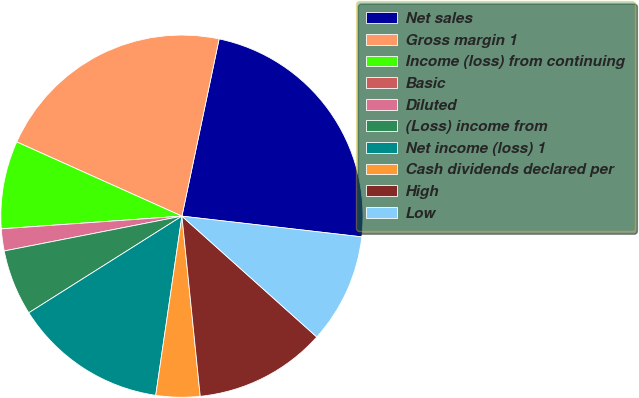<chart> <loc_0><loc_0><loc_500><loc_500><pie_chart><fcel>Net sales<fcel>Gross margin 1<fcel>Income (loss) from continuing<fcel>Basic<fcel>Diluted<fcel>(Loss) income from<fcel>Net income (loss) 1<fcel>Cash dividends declared per<fcel>High<fcel>Low<nl><fcel>23.53%<fcel>21.57%<fcel>7.84%<fcel>0.0%<fcel>1.96%<fcel>5.88%<fcel>13.73%<fcel>3.92%<fcel>11.76%<fcel>9.8%<nl></chart> 